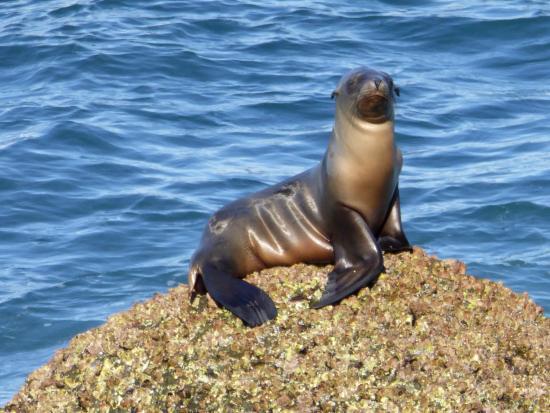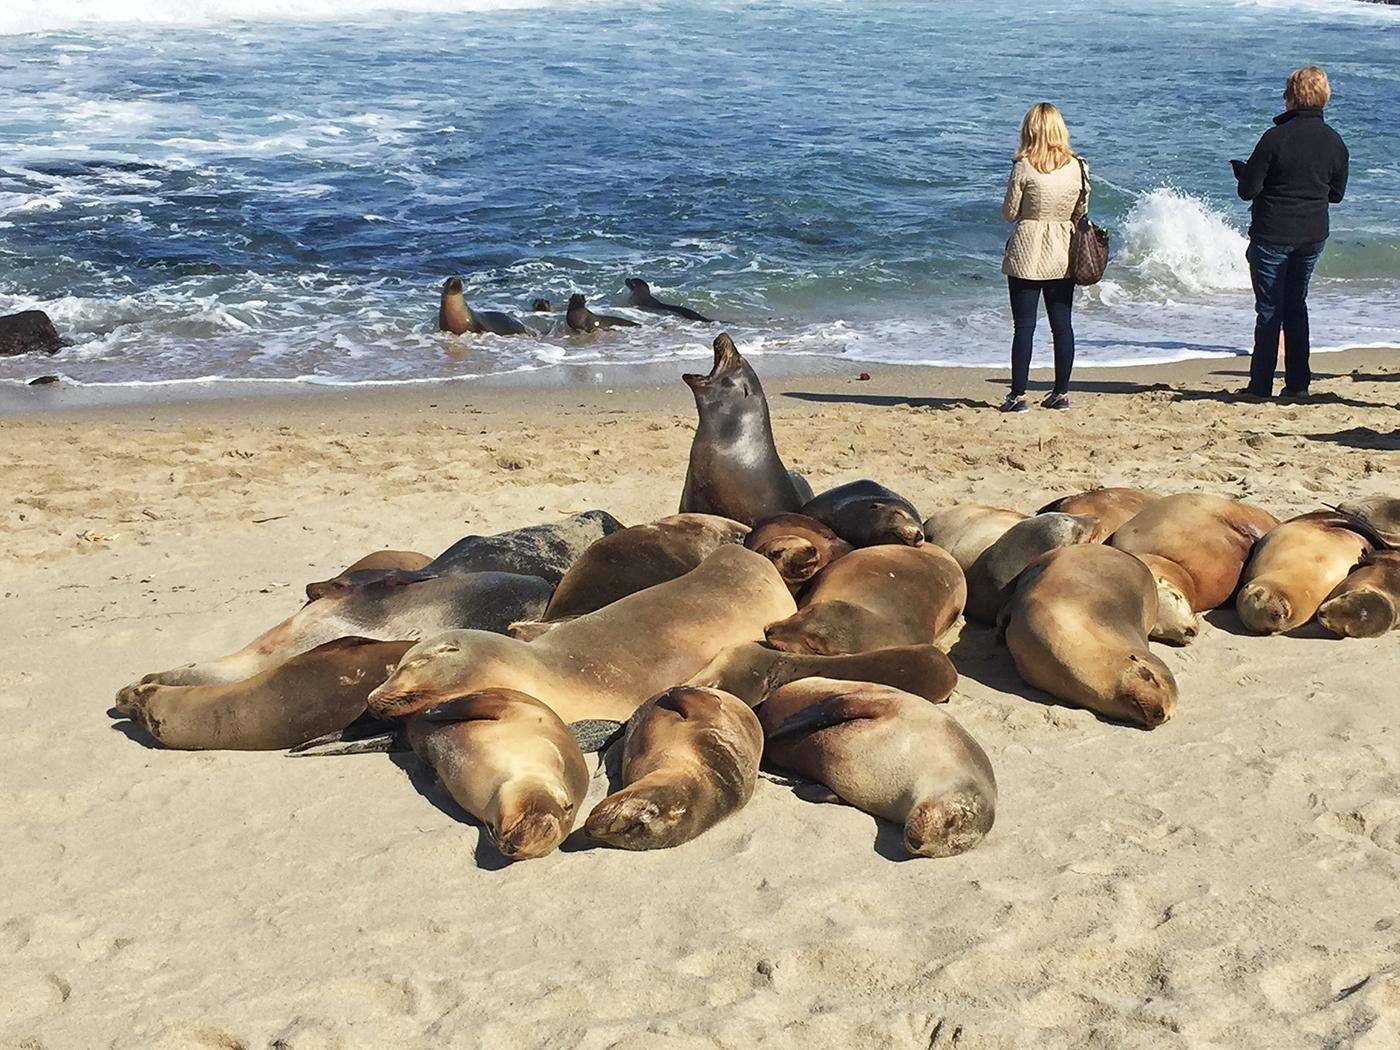The first image is the image on the left, the second image is the image on the right. Assess this claim about the two images: "There are two sea lions in one of the images.". Correct or not? Answer yes or no. No. The first image is the image on the left, the second image is the image on the right. Evaluate the accuracy of this statement regarding the images: "There is at least one image where the sea lions are lying in the sand.". Is it true? Answer yes or no. Yes. 